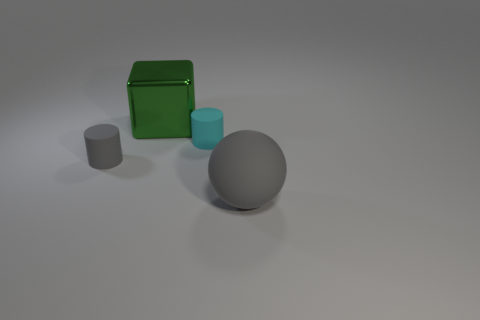What number of other matte objects have the same color as the big matte object?
Provide a short and direct response. 1. Is there any other thing that is the same material as the cyan object?
Provide a succinct answer. Yes. Is the number of cyan matte objects to the left of the green thing less than the number of large gray things?
Ensure brevity in your answer.  Yes. What is the color of the rubber cylinder to the left of the matte cylinder on the right side of the block?
Provide a succinct answer. Gray. What size is the object that is to the left of the green object to the left of the tiny object that is to the right of the big green block?
Make the answer very short. Small. Is the number of big metallic cubes that are in front of the large metal thing less than the number of large rubber spheres that are behind the gray matte ball?
Provide a short and direct response. No. How many gray cylinders are made of the same material as the big gray sphere?
Your answer should be very brief. 1. There is a small object that is in front of the tiny matte cylinder on the right side of the gray cylinder; are there any small things behind it?
Provide a short and direct response. Yes. There is a big gray thing that is the same material as the tiny cyan object; what shape is it?
Your response must be concise. Sphere. Are there more large yellow metal blocks than gray objects?
Provide a succinct answer. No. 